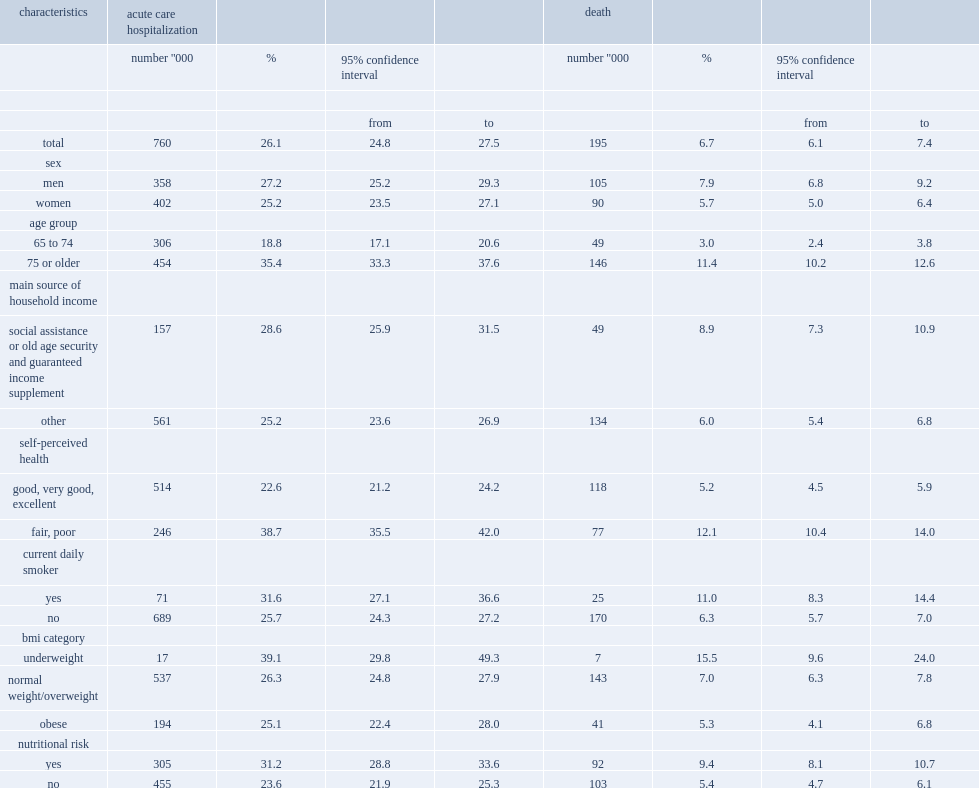What is the proportion of seniors who were hospitalized at least once during the follow-up period to all seniors in canada? 26.1. Which age groups were more likely to have been hospitalized, older seniors or those aged 65 to 75? 75 or older. Whih group of seniors has a significantly higher precentage of acute care hospitalization during the follow-up period, those be at nutritional risk or those not at nutritional risk? Yes. What is the estimated percent of senior population died during the follow-up period? 6.7. Which group of seniors were more likely to die, those at nutritional risk or those not at risk? Yes. 